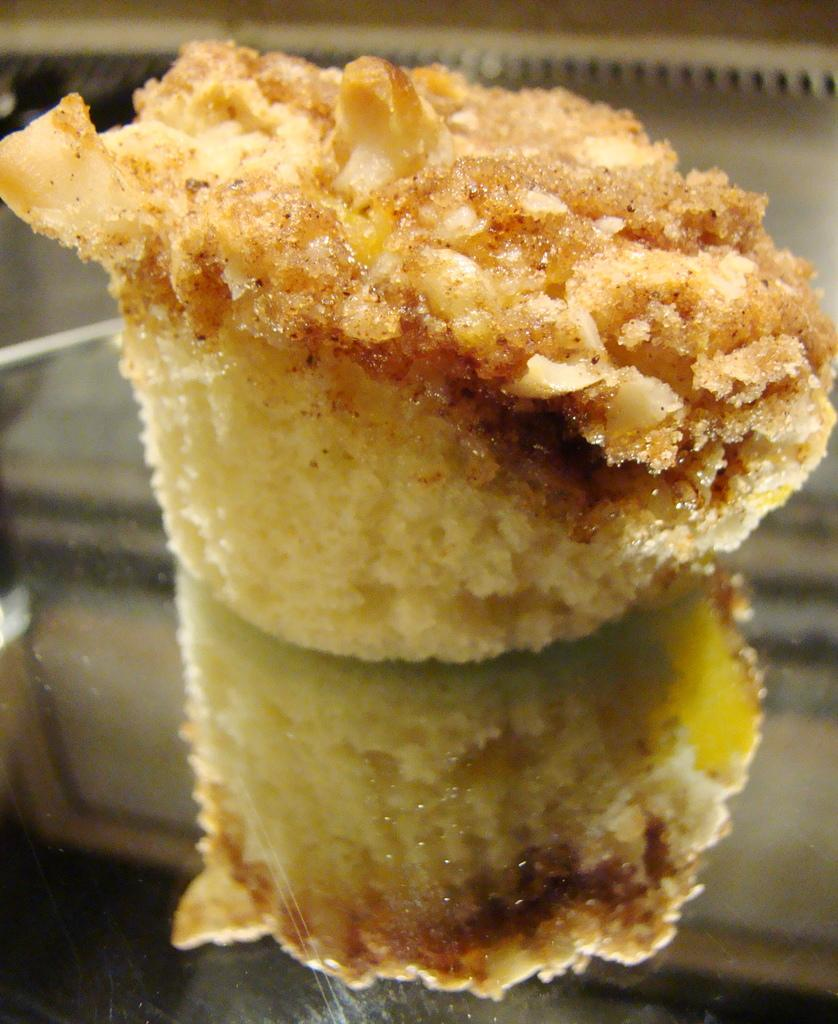What is on the plate in the image? There is food on a plate in the image. Can you describe any additional details about the food on the plate? There is a reflection of the food on the plate in the image. What type of eggnog is being served in the image? There is no eggnog present in the image; it only features food on a plate and its reflection. 